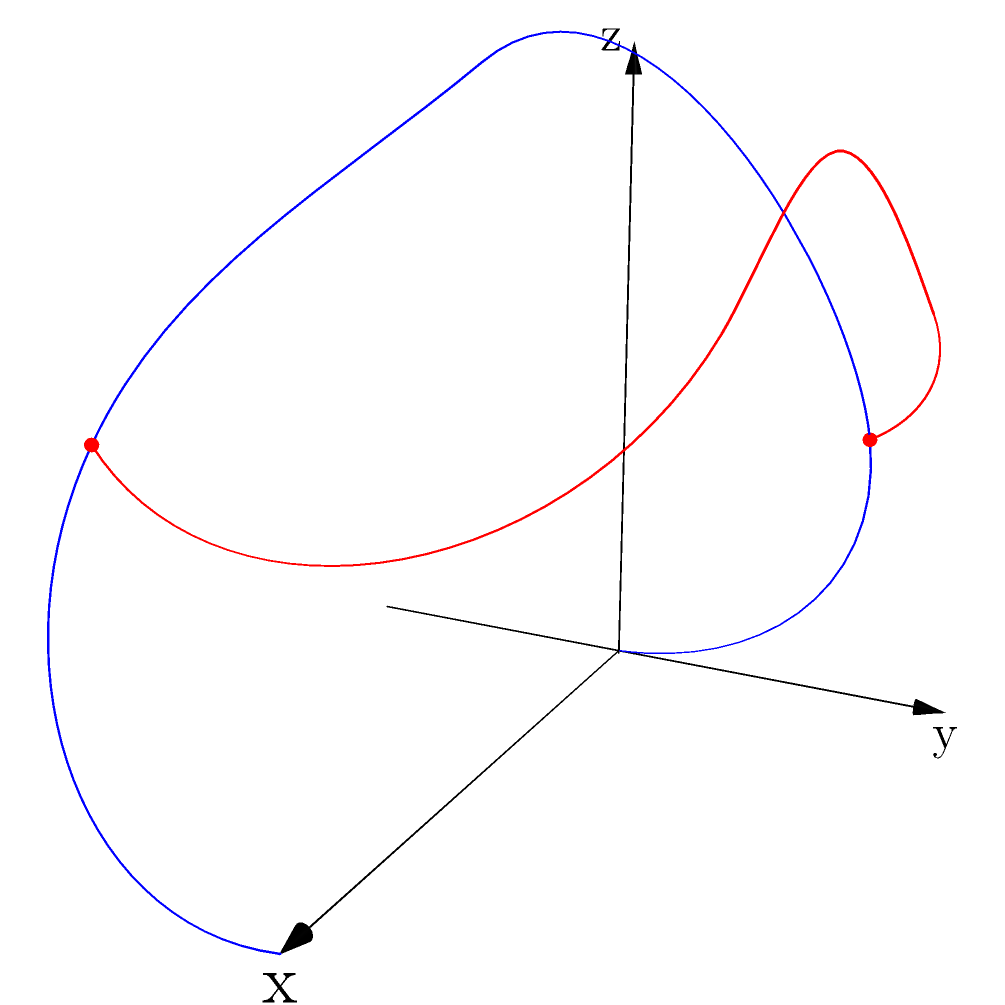Given a 2D track layout for a toy car race, you need to transform it into a 3D representation with banked turns and elevation changes. The track starts at (0,0,0) and ends at (4,0,0), with a total length of 4 units. Two key points on the track are at (1,1) and (3,-1) in the 2D layout. If you want to create a banked turn with a maximum elevation of 0.9 units at the midpoint between these two key points, what would be the coordinates $(x,y,z)$ of this highest point in the 3D representation? To solve this problem, we need to follow these steps:

1) First, we need to determine the z-coordinates of the two key points. Given that the track has elevation changes, let's assume these points are at a height of 0.5 units. So in 3D, they become (1,1,0.5) and (3,-1,0.5).

2) The midpoint between these two points in the x-y plane is:
   $x = \frac{1+3}{2} = 2$
   $y = \frac{1+(-1)}{2} = 0$

3) The z-coordinate of this midpoint, without banking, would be 0.5 (same as the key points). However, we want to raise this to 0.9 units for the banked turn.

4) Therefore, the coordinates of the highest point of the banked turn are (2,0,0.9).

This point represents the peak of the banked turn, providing both elevation change and allowing for a smooth transition between the two key points of the track.
Answer: (2,0,0.9) 